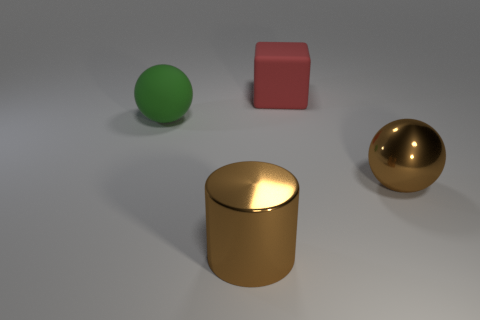Add 1 metal balls. How many objects exist? 5 Subtract all blocks. How many objects are left? 3 Subtract 0 purple spheres. How many objects are left? 4 Subtract all large brown balls. Subtract all cubes. How many objects are left? 2 Add 2 big rubber blocks. How many big rubber blocks are left? 3 Add 3 gray matte cylinders. How many gray matte cylinders exist? 3 